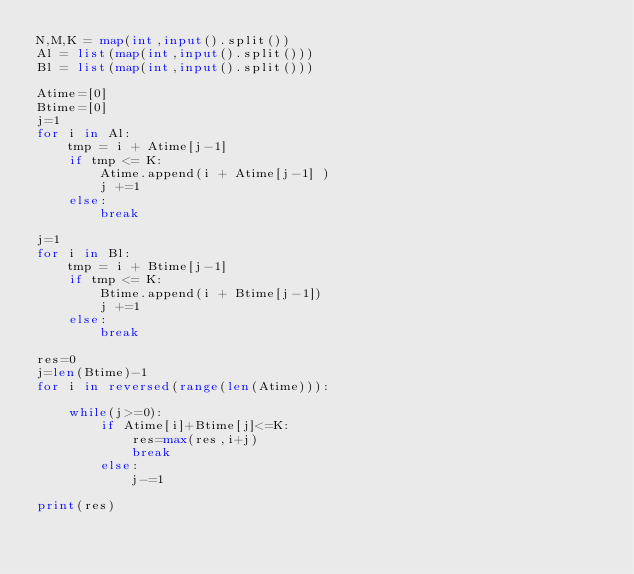<code> <loc_0><loc_0><loc_500><loc_500><_Python_>N,M,K = map(int,input().split())
Al = list(map(int,input().split()))
Bl = list(map(int,input().split()))

Atime=[0]
Btime=[0]
j=1
for i in Al:
    tmp = i + Atime[j-1]
    if tmp <= K: 
        Atime.append(i + Atime[j-1] )
        j +=1
    else:
        break

j=1
for i in Bl:
    tmp = i + Btime[j-1]
    if tmp <= K:
        Btime.append(i + Btime[j-1])
        j +=1
    else:
        break

res=0
j=len(Btime)-1
for i in reversed(range(len(Atime))):

    while(j>=0):
        if Atime[i]+Btime[j]<=K:
            res=max(res,i+j)
            break
        else:
            j-=1        

print(res)</code> 